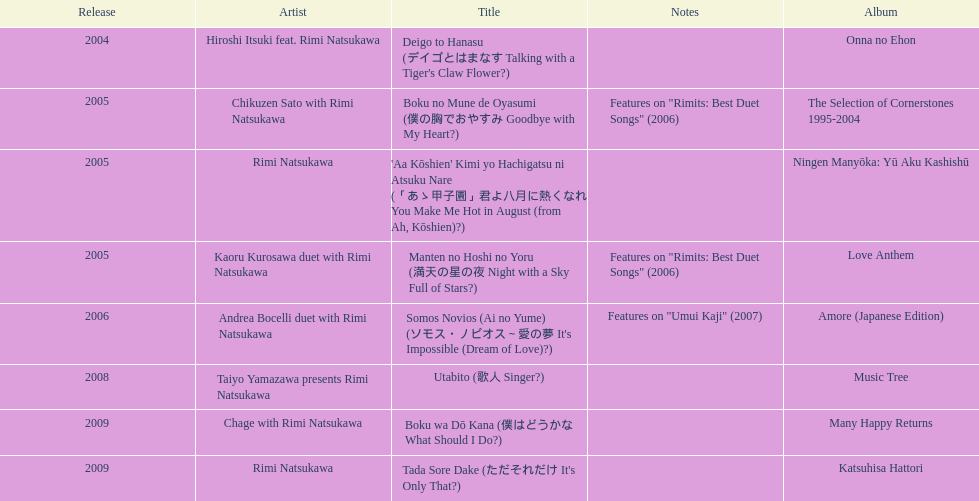Which title has the same notes as night with a sky full of stars? Boku no Mune de Oyasumi (僕の胸でおやすみ Goodbye with My Heart?). 